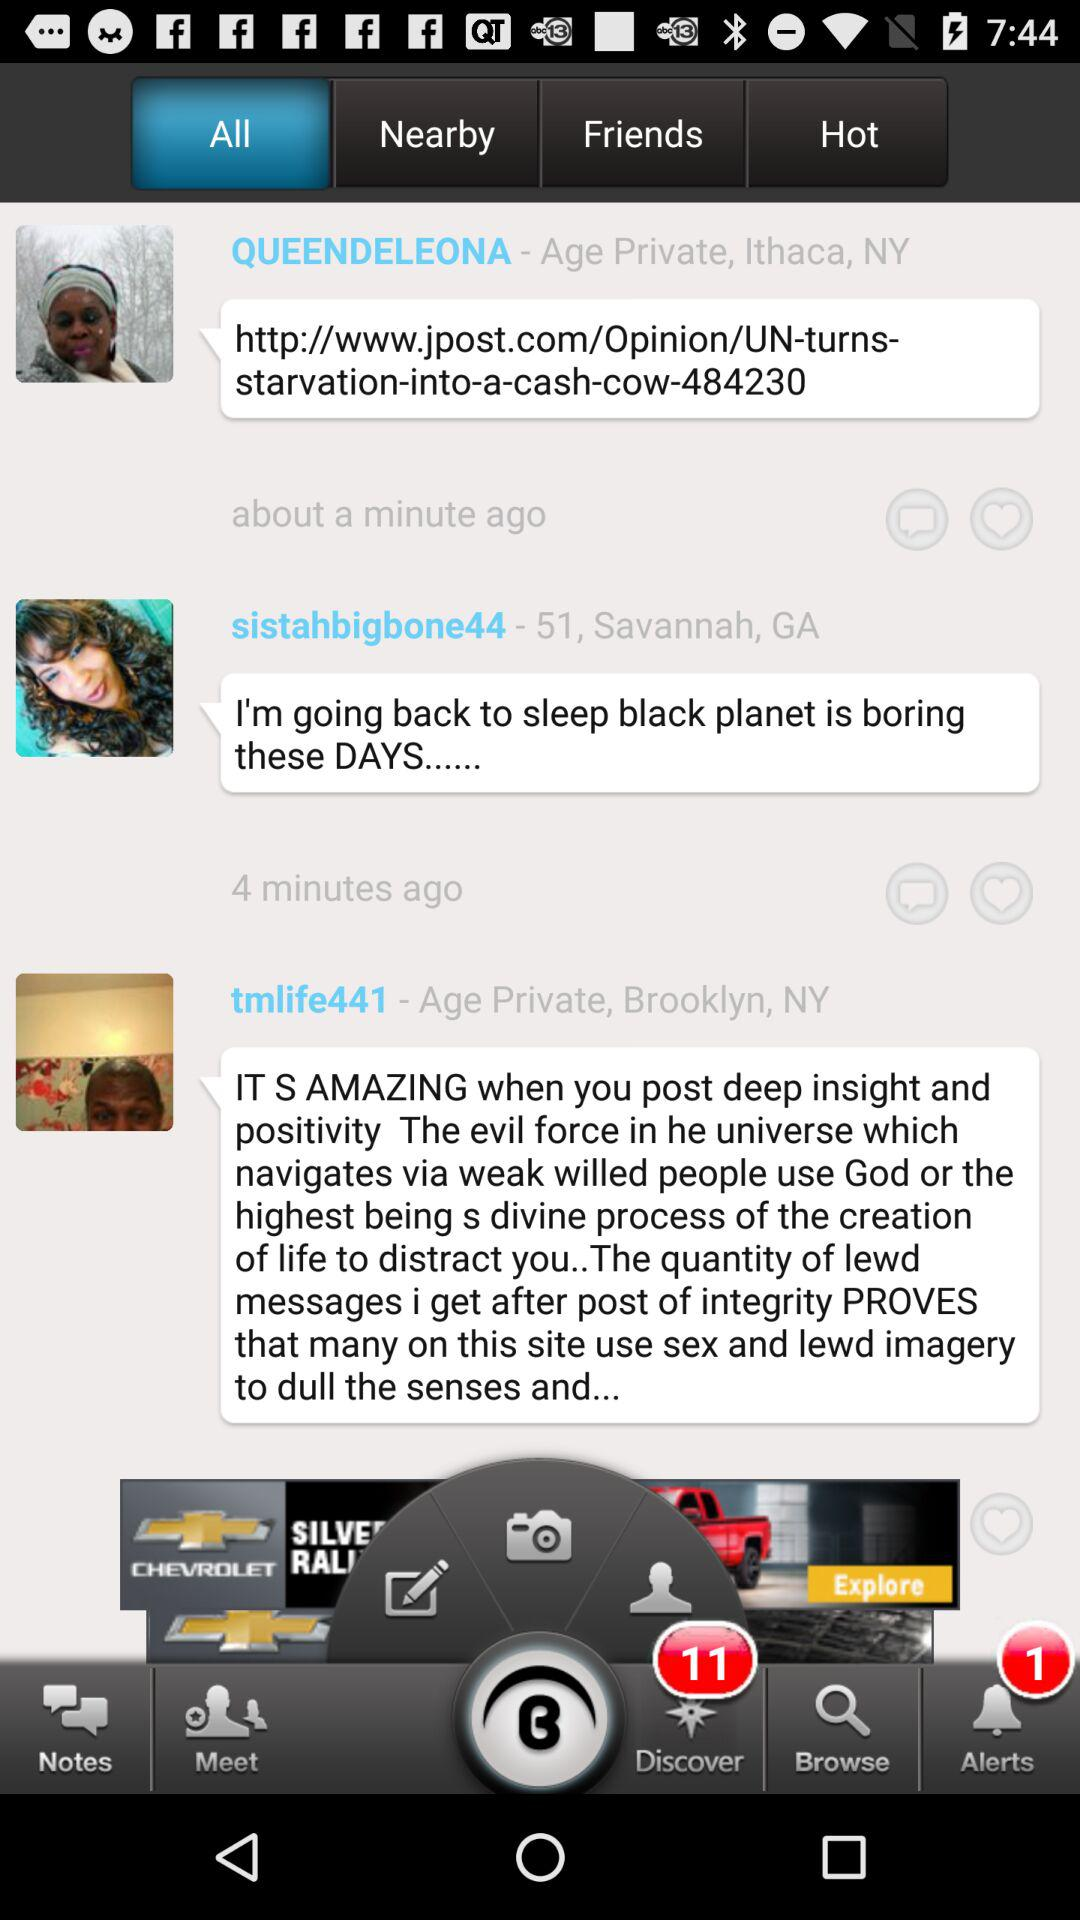How many notifications in total are there in "Discover"? There are 11 notifications in "Discover". 